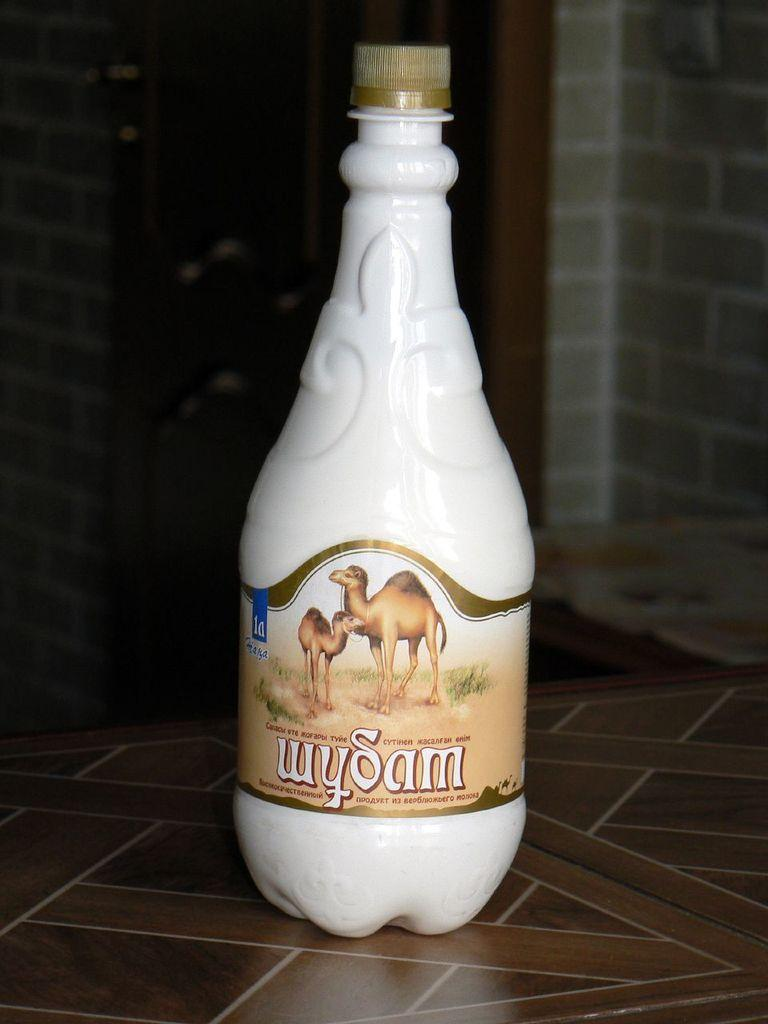What object is placed on the table in the image? There is a bottle on the table. What can be seen in the background of the image? There is a wall visible in the background of the image. What type of event is taking place in the image? There is no indication of any event taking place in the image. What loss is being experienced by the person in the image? There is no person or loss depicted in the image; it only features a bottle on a table and a wall in the background. 